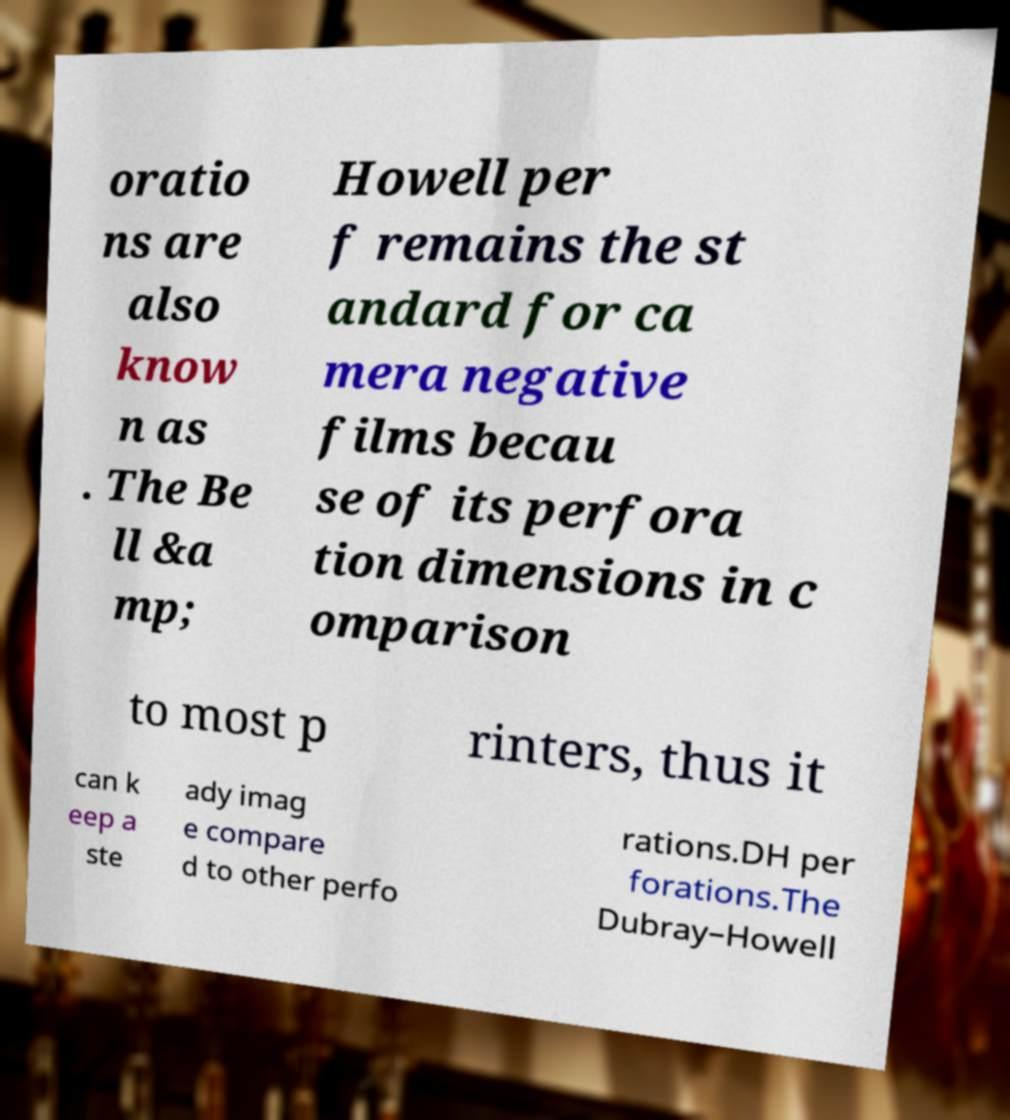I need the written content from this picture converted into text. Can you do that? oratio ns are also know n as . The Be ll &a mp; Howell per f remains the st andard for ca mera negative films becau se of its perfora tion dimensions in c omparison to most p rinters, thus it can k eep a ste ady imag e compare d to other perfo rations.DH per forations.The Dubray–Howell 